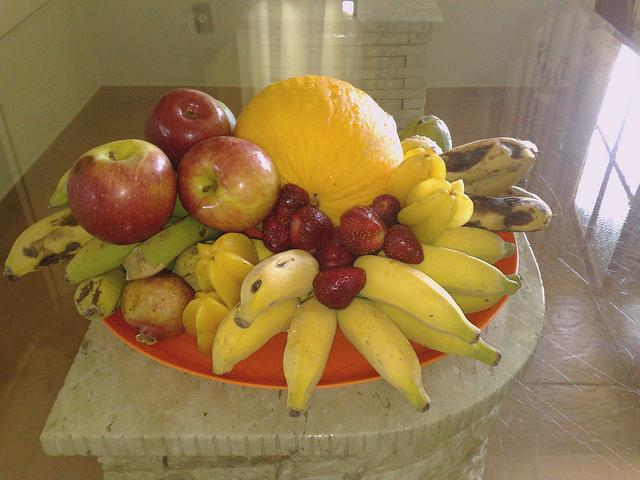What color is the largest fruit on the plate?

Choices:
A) brown
B) green
C) yellow
D) red yellow 